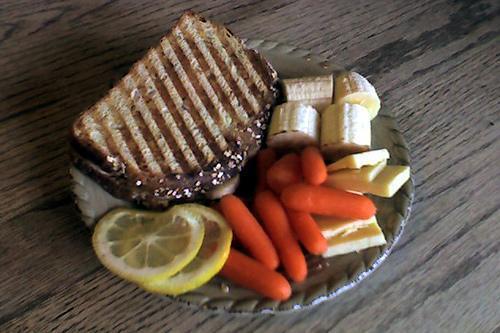How many carrots are in the photo?
Give a very brief answer. 2. How many oranges are there?
Give a very brief answer. 2. How many motorcycles are a different color?
Give a very brief answer. 0. 